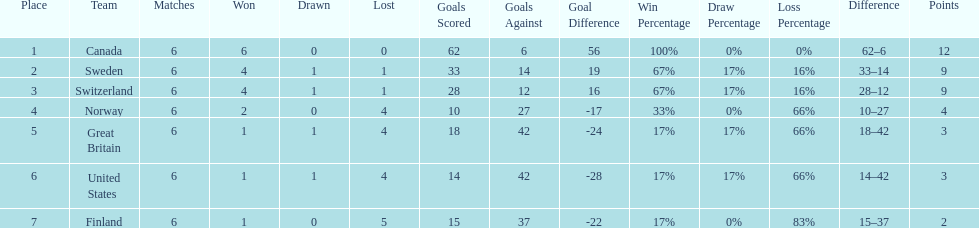During the 1951 world ice hockey championships, what was the difference between the first and last place teams for number of games won ? 5. 